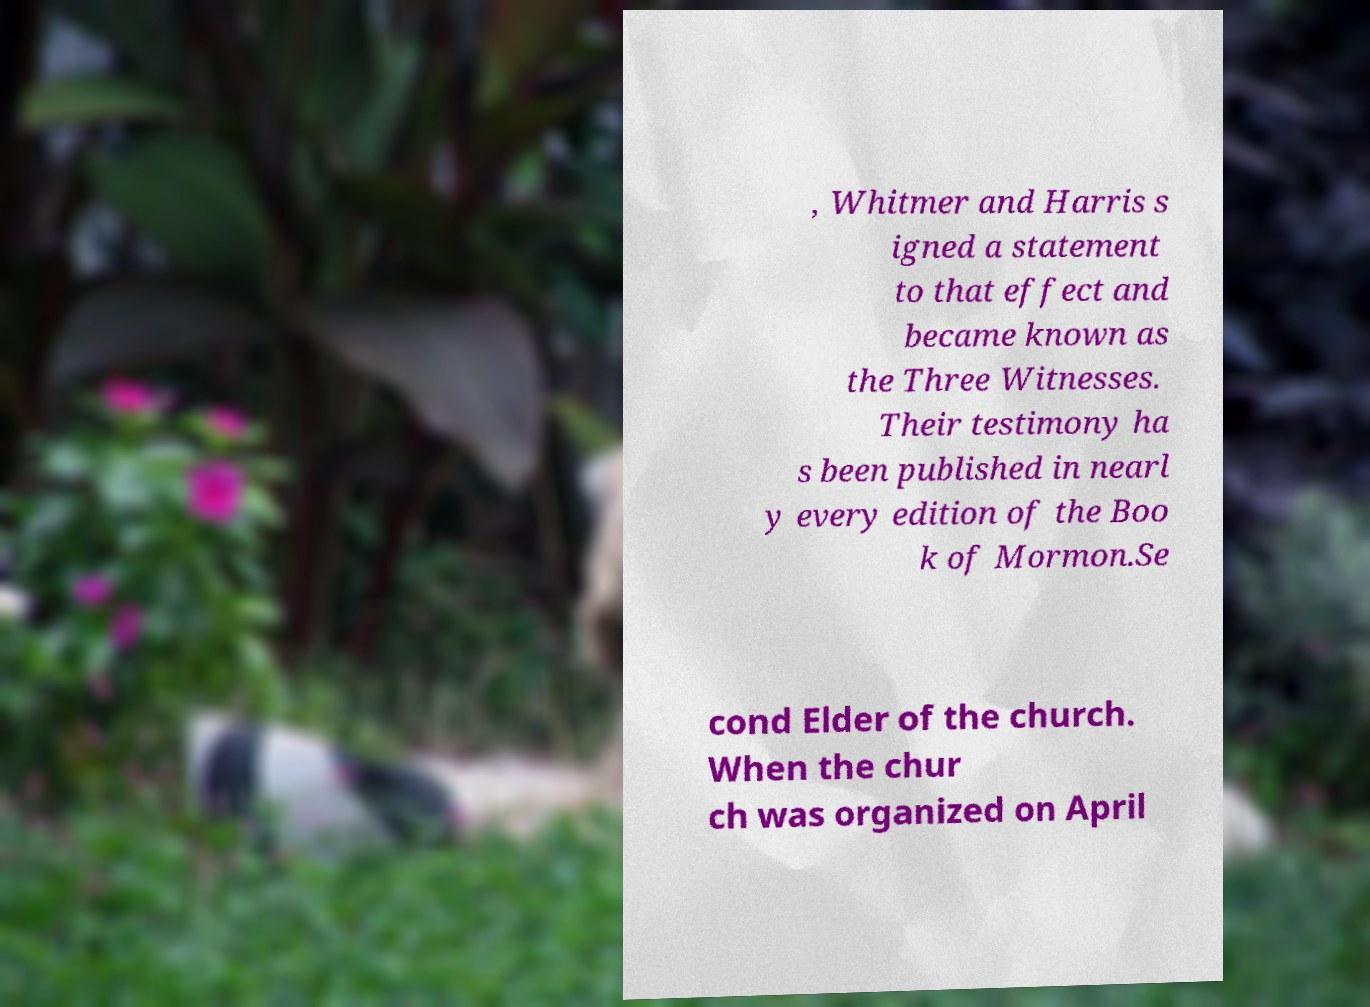Could you assist in decoding the text presented in this image and type it out clearly? , Whitmer and Harris s igned a statement to that effect and became known as the Three Witnesses. Their testimony ha s been published in nearl y every edition of the Boo k of Mormon.Se cond Elder of the church. When the chur ch was organized on April 